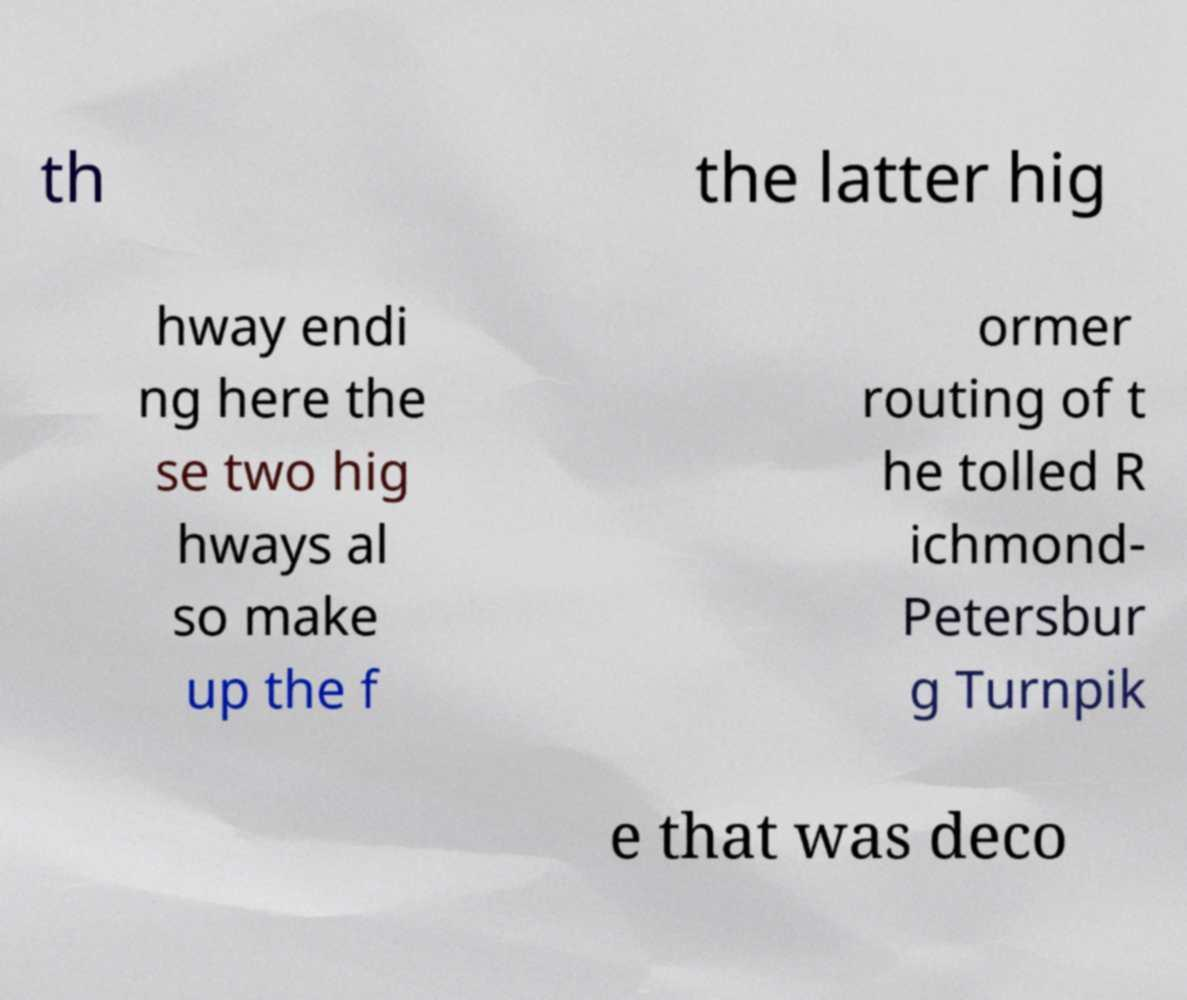Can you accurately transcribe the text from the provided image for me? th the latter hig hway endi ng here the se two hig hways al so make up the f ormer routing of t he tolled R ichmond- Petersbur g Turnpik e that was deco 